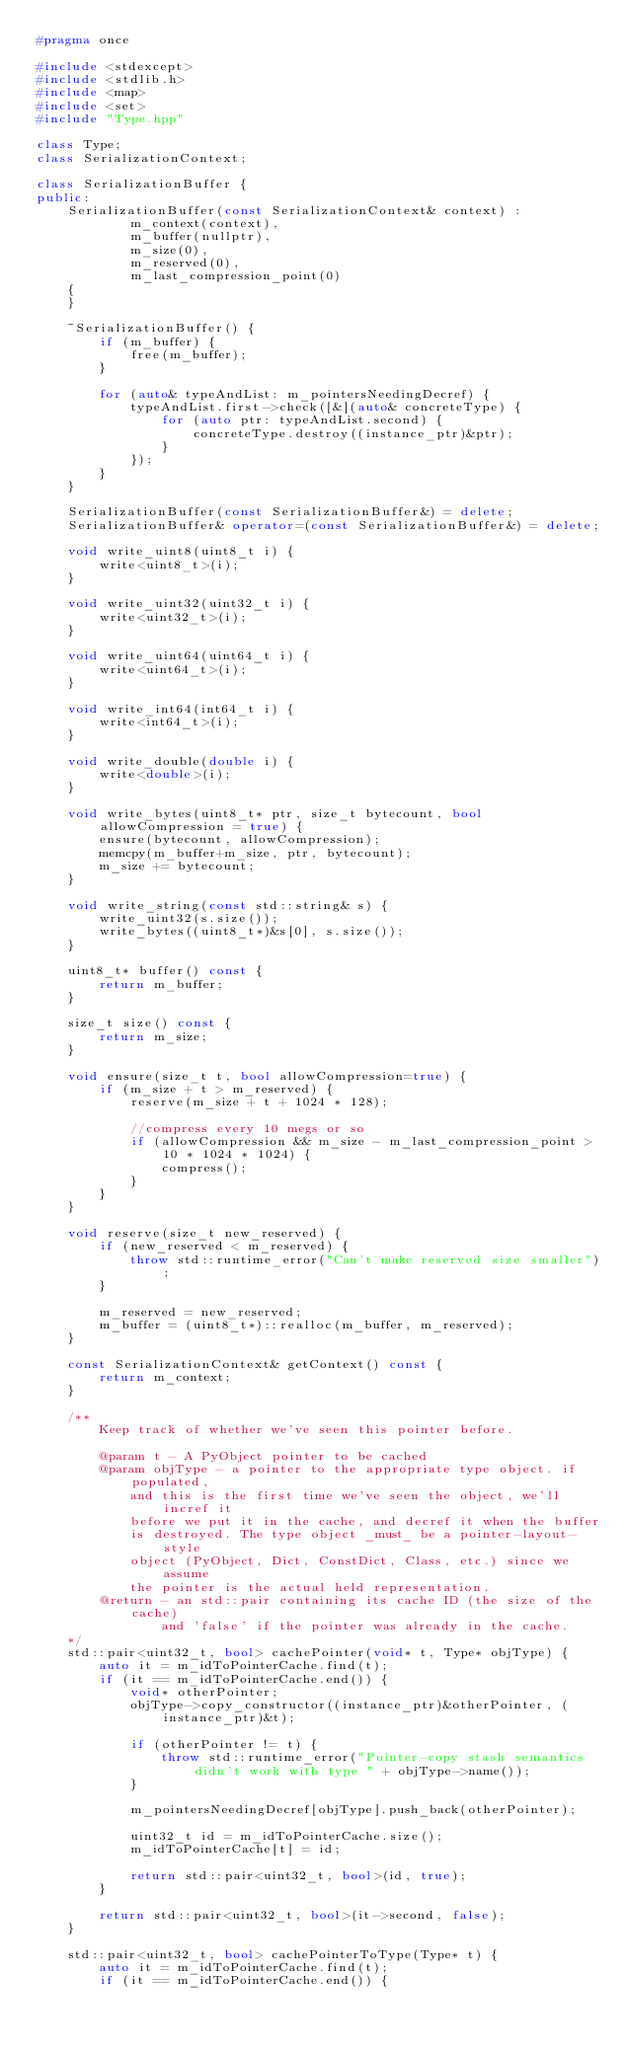<code> <loc_0><loc_0><loc_500><loc_500><_C++_>#pragma once

#include <stdexcept>
#include <stdlib.h>
#include <map>
#include <set>
#include "Type.hpp"

class Type;
class SerializationContext;

class SerializationBuffer {
public:
    SerializationBuffer(const SerializationContext& context) :
            m_context(context),
            m_buffer(nullptr),
            m_size(0),
            m_reserved(0),
            m_last_compression_point(0)
    {
    }

    ~SerializationBuffer() {
        if (m_buffer) {
            free(m_buffer);
        }

        for (auto& typeAndList: m_pointersNeedingDecref) {
            typeAndList.first->check([&](auto& concreteType) {
                for (auto ptr: typeAndList.second) {
                    concreteType.destroy((instance_ptr)&ptr);
                }
            });
        }
    }

    SerializationBuffer(const SerializationBuffer&) = delete;
    SerializationBuffer& operator=(const SerializationBuffer&) = delete;

    void write_uint8(uint8_t i) {
        write<uint8_t>(i);
    }

    void write_uint32(uint32_t i) {
        write<uint32_t>(i);
    }

    void write_uint64(uint64_t i) {
        write<uint64_t>(i);
    }

    void write_int64(int64_t i) {
        write<int64_t>(i);
    }

    void write_double(double i) {
        write<double>(i);
    }

    void write_bytes(uint8_t* ptr, size_t bytecount, bool allowCompression = true) {
        ensure(bytecount, allowCompression);
        memcpy(m_buffer+m_size, ptr, bytecount);
        m_size += bytecount;
    }

    void write_string(const std::string& s) {
        write_uint32(s.size());
        write_bytes((uint8_t*)&s[0], s.size());
    }

    uint8_t* buffer() const {
        return m_buffer;
    }

    size_t size() const {
        return m_size;
    }

    void ensure(size_t t, bool allowCompression=true) {
        if (m_size + t > m_reserved) {
            reserve(m_size + t + 1024 * 128);

            //compress every 10 megs or so
            if (allowCompression && m_size - m_last_compression_point > 10 * 1024 * 1024) {
                compress();
            }
        }
    }

    void reserve(size_t new_reserved) {
        if (new_reserved < m_reserved) {
            throw std::runtime_error("Can't make reserved size smaller");
        }

        m_reserved = new_reserved;
        m_buffer = (uint8_t*)::realloc(m_buffer, m_reserved);
    }

    const SerializationContext& getContext() const {
        return m_context;
    }

    /**
        Keep track of whether we've seen this pointer before.

        @param t - A PyObject pointer to be cached
        @param objType - a pointer to the appropriate type object. if populated,
            and this is the first time we've seen the object, we'll incref it
            before we put it in the cache, and decref it when the buffer
            is destroyed. The type object _must_ be a pointer-layout-style
            object (PyObject, Dict, ConstDict, Class, etc.) since we assume
            the pointer is the actual held representation.
        @return - an std::pair containing its cache ID (the size of the cache)
                and 'false' if the pointer was already in the cache.
    */
    std::pair<uint32_t, bool> cachePointer(void* t, Type* objType) {
        auto it = m_idToPointerCache.find(t);
        if (it == m_idToPointerCache.end()) {
            void* otherPointer;
            objType->copy_constructor((instance_ptr)&otherPointer, (instance_ptr)&t);

            if (otherPointer != t) {
                throw std::runtime_error("Pointer-copy stash semantics didn't work with type " + objType->name());
            }

            m_pointersNeedingDecref[objType].push_back(otherPointer);

            uint32_t id = m_idToPointerCache.size();
            m_idToPointerCache[t] = id;

            return std::pair<uint32_t, bool>(id, true);
        }

        return std::pair<uint32_t, bool>(it->second, false);
    }

    std::pair<uint32_t, bool> cachePointerToType(Type* t) {
        auto it = m_idToPointerCache.find(t);
        if (it == m_idToPointerCache.end()) {</code> 